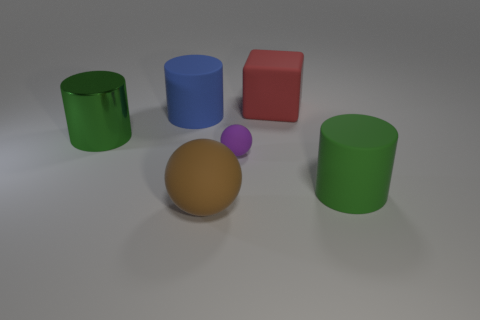Add 3 big yellow things. How many objects exist? 9 Subtract all spheres. How many objects are left? 4 Subtract 0 red spheres. How many objects are left? 6 Subtract all matte spheres. Subtract all large metal things. How many objects are left? 3 Add 6 blue cylinders. How many blue cylinders are left? 7 Add 3 blue matte things. How many blue matte things exist? 4 